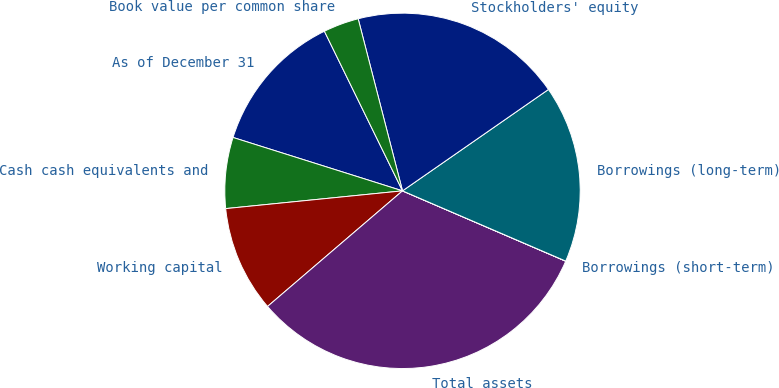Convert chart. <chart><loc_0><loc_0><loc_500><loc_500><pie_chart><fcel>As of December 31<fcel>Cash cash equivalents and<fcel>Working capital<fcel>Total assets<fcel>Borrowings (short-term)<fcel>Borrowings (long-term)<fcel>Stockholders' equity<fcel>Book value per common share<nl><fcel>12.9%<fcel>6.45%<fcel>9.68%<fcel>32.25%<fcel>0.01%<fcel>16.13%<fcel>19.35%<fcel>3.23%<nl></chart> 